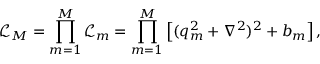<formula> <loc_0><loc_0><loc_500><loc_500>\mathcal { L } _ { M } = \prod _ { m = 1 } ^ { M } \mathcal { L } _ { m } = \prod _ { m = 1 } ^ { M } \left [ ( q _ { m } ^ { 2 } + \nabla ^ { 2 } ) ^ { 2 } + b _ { m } \right ] ,</formula> 